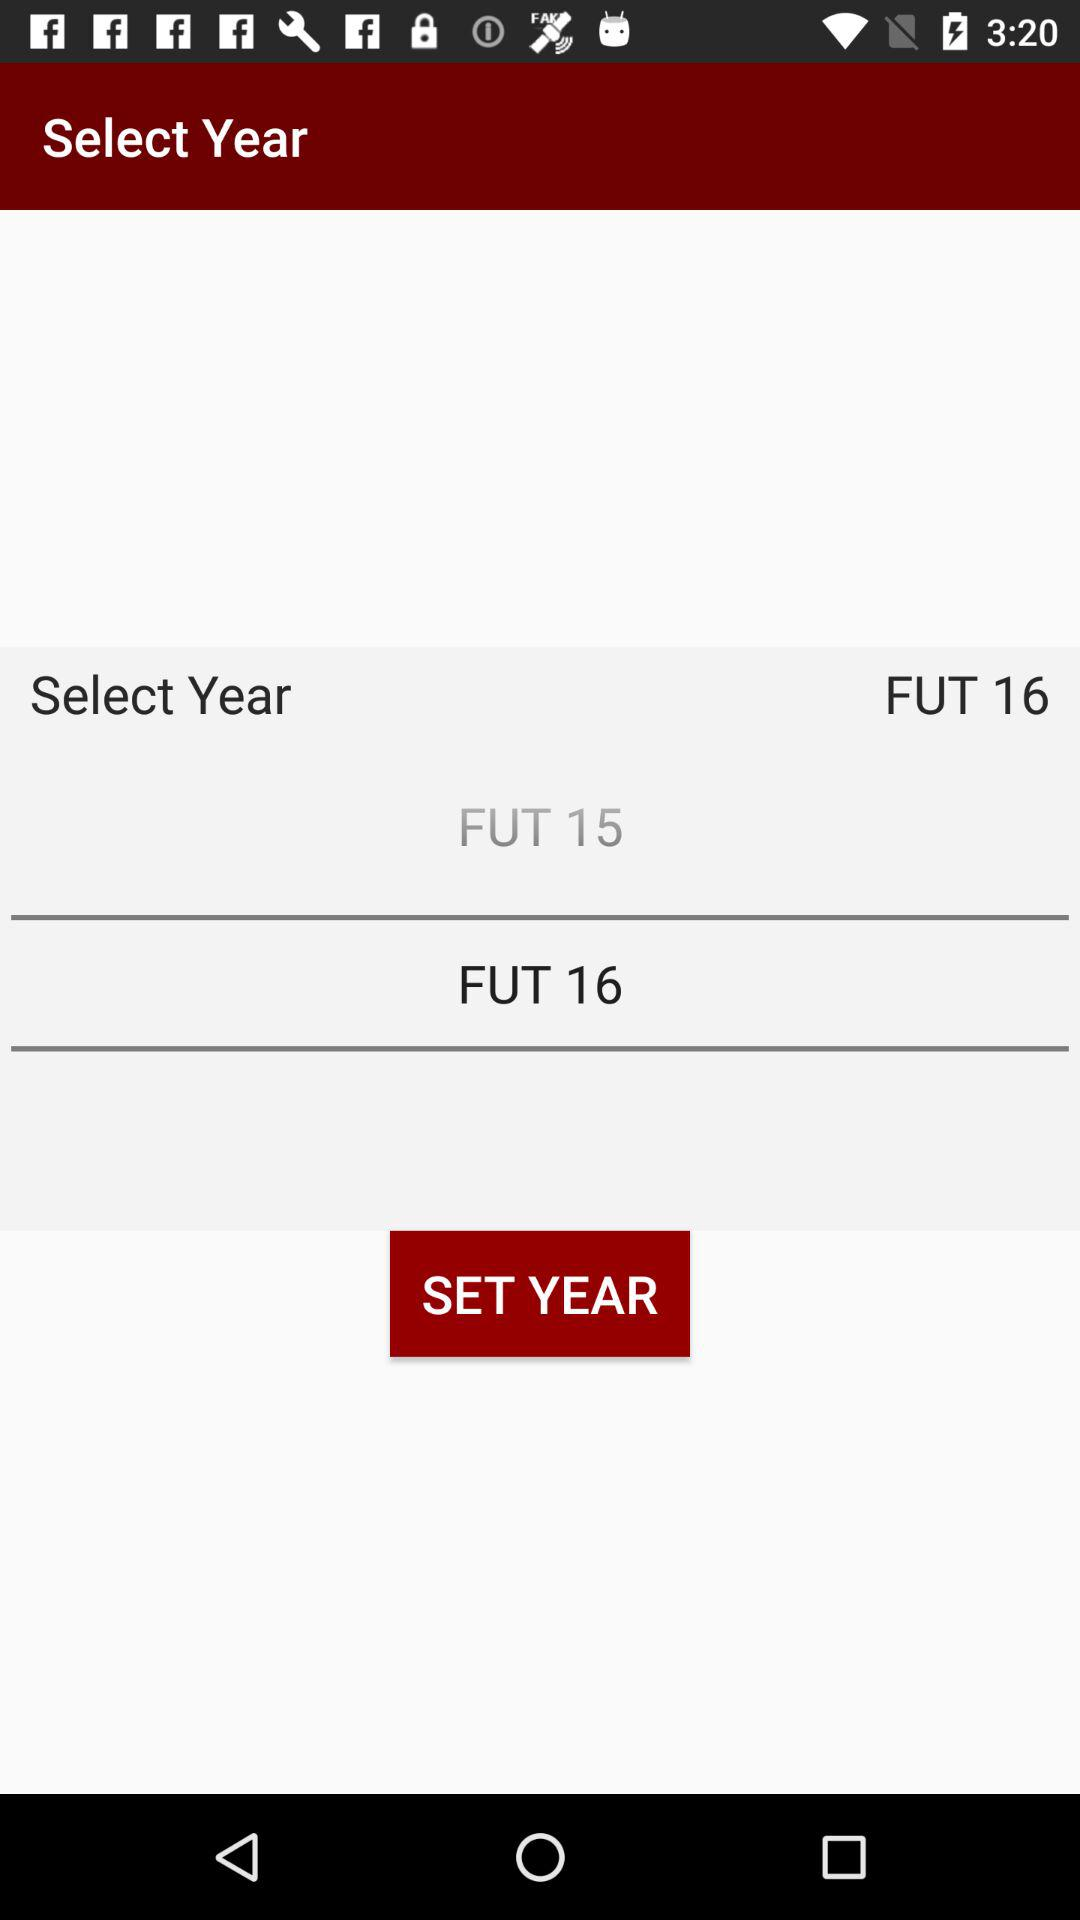How many years are available to select from?
Answer the question using a single word or phrase. 2 